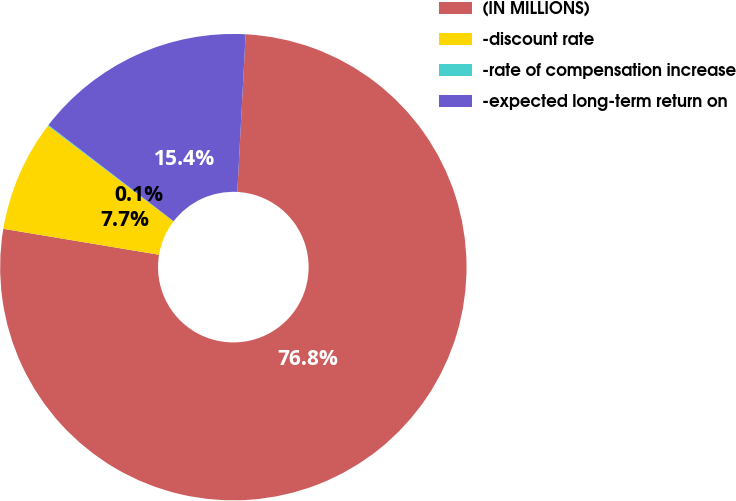<chart> <loc_0><loc_0><loc_500><loc_500><pie_chart><fcel>(IN MILLIONS)<fcel>-discount rate<fcel>-rate of compensation increase<fcel>-expected long-term return on<nl><fcel>76.79%<fcel>7.74%<fcel>0.06%<fcel>15.41%<nl></chart> 